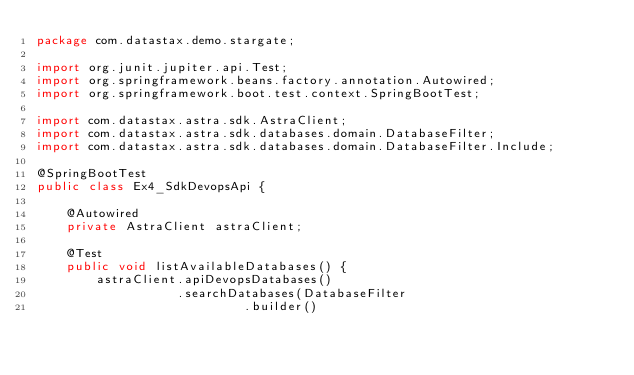Convert code to text. <code><loc_0><loc_0><loc_500><loc_500><_Java_>package com.datastax.demo.stargate;

import org.junit.jupiter.api.Test;
import org.springframework.beans.factory.annotation.Autowired;
import org.springframework.boot.test.context.SpringBootTest;

import com.datastax.astra.sdk.AstraClient;
import com.datastax.astra.sdk.databases.domain.DatabaseFilter;
import com.datastax.astra.sdk.databases.domain.DatabaseFilter.Include;

@SpringBootTest
public class Ex4_SdkDevopsApi {

    @Autowired
    private AstraClient astraClient;
    
    @Test
    public void listAvailableDatabases() {
        astraClient.apiDevopsDatabases()
                   .searchDatabases(DatabaseFilter
                            .builder()</code> 